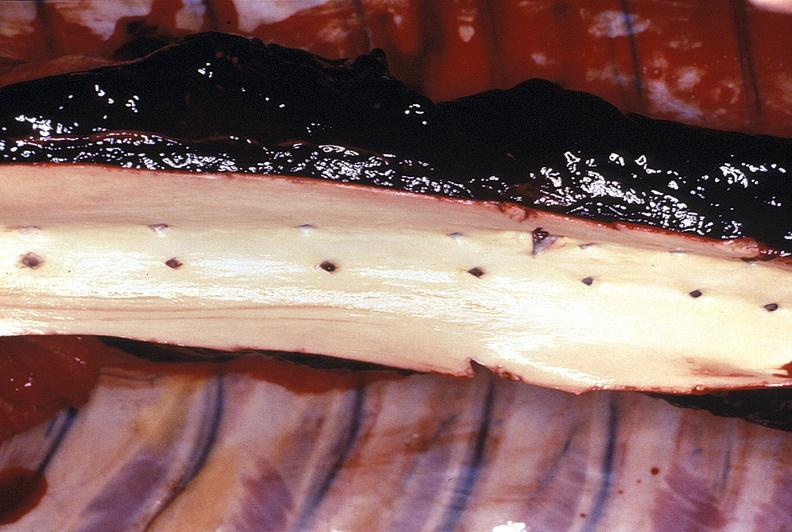s papillary intraductal adenocarcinoma present?
Answer the question using a single word or phrase. No 